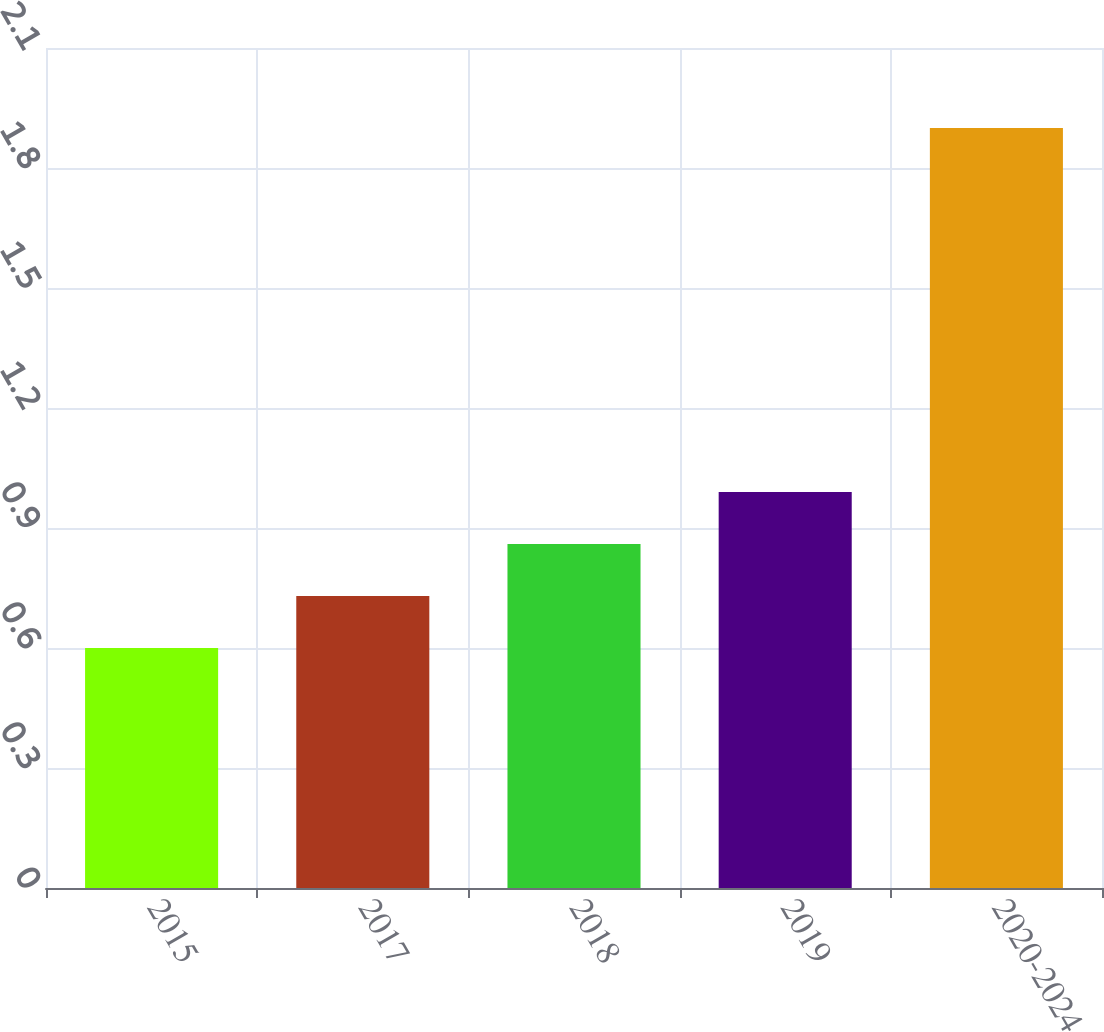Convert chart to OTSL. <chart><loc_0><loc_0><loc_500><loc_500><bar_chart><fcel>2015<fcel>2017<fcel>2018<fcel>2019<fcel>2020-2024<nl><fcel>0.6<fcel>0.73<fcel>0.86<fcel>0.99<fcel>1.9<nl></chart> 